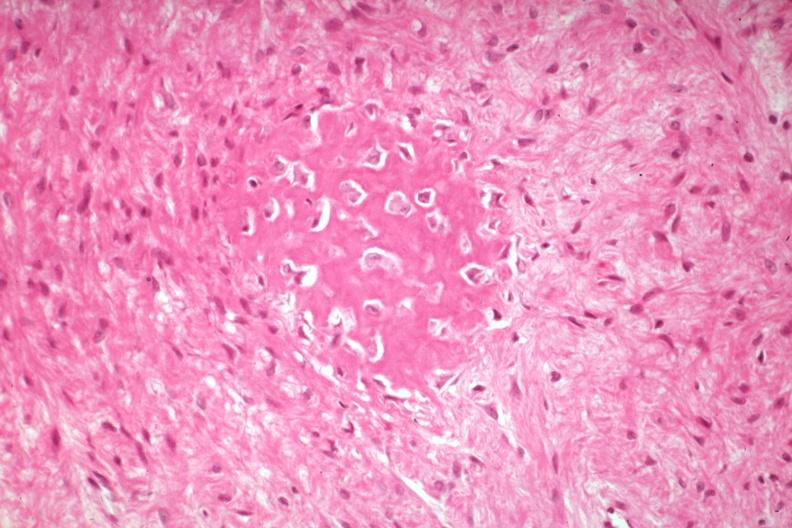what is present?
Answer the question using a single word or phrase. Joints 